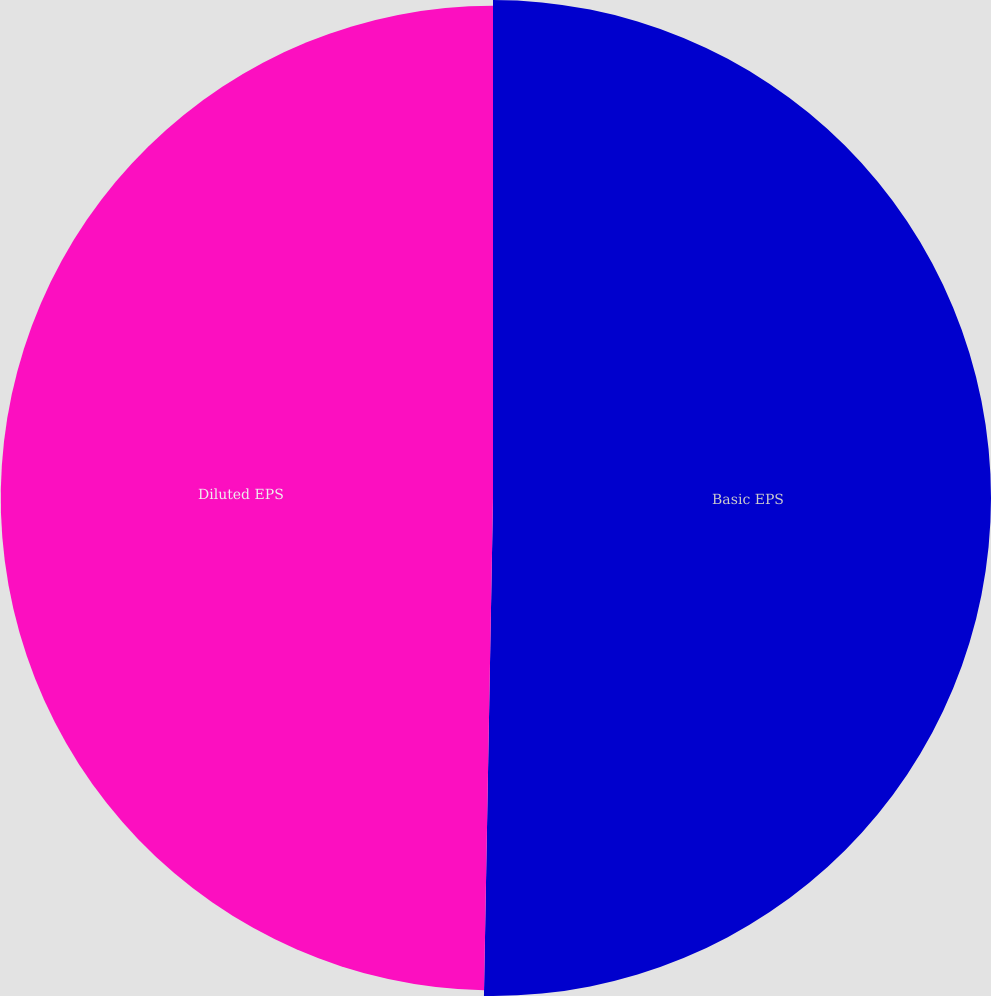<chart> <loc_0><loc_0><loc_500><loc_500><pie_chart><fcel>Basic EPS<fcel>Diluted EPS<nl><fcel>50.29%<fcel>49.71%<nl></chart> 